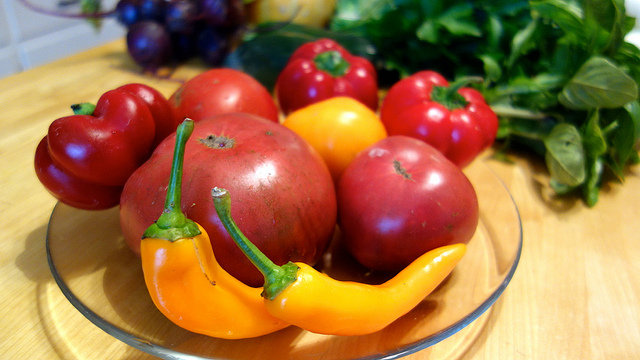Could you suggest a dish one could prepare with these vegetables? Certainly! With the bell peppers, tomatoes, chili pepper, and leafy greens, you could make a vibrant and spicy vegetable stir-fry. You could also consider making a hearty vegetable stew or a fresh garden salad to highlight the freshness of these ingredients. 